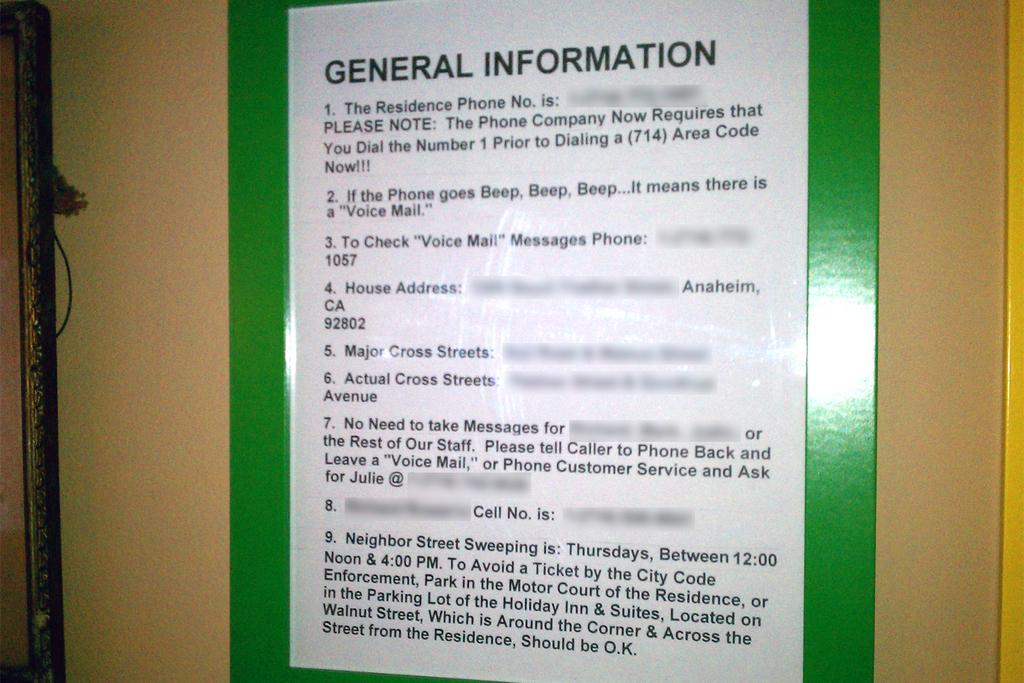<image>
Present a compact description of the photo's key features. a white and green paper with general information on it 